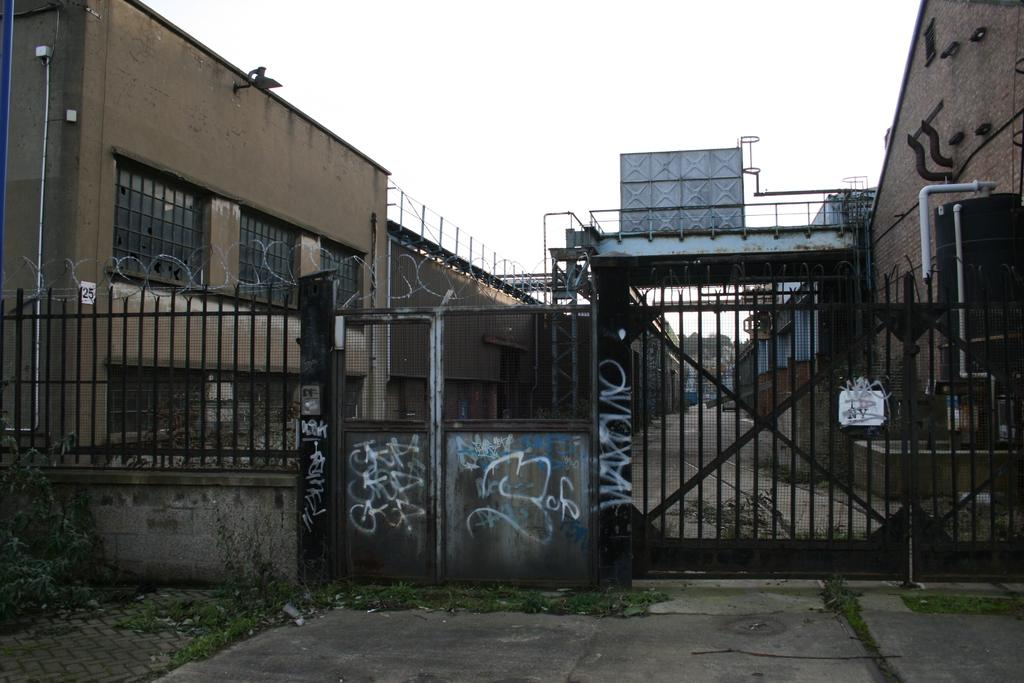What type of structure can be seen in the image? There is a wall in the image. What other structures are present in the image? There is a fence and a gate in the image. What can be found growing in the image? There are plants in the image. What type of man-made structures are visible in the image? There are buildings in the image. What else can be seen in the image besides structures and plants? There are objects in the image. What is visible in the background of the image? The sky is visible in the background of the image. What type of beef is being prepared in the image? There is no beef present in the image; it does not depict any food preparation. 